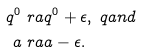Convert formula to latex. <formula><loc_0><loc_0><loc_500><loc_500>q ^ { 0 } & \ r a q ^ { 0 } + \epsilon , \ q a n d \\ a & \ r a a - \epsilon .</formula> 